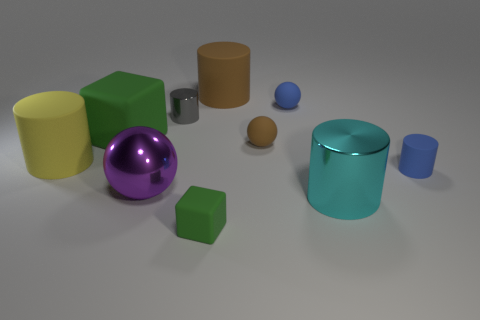There is a rubber thing that is behind the gray cylinder and left of the brown ball; how big is it?
Your response must be concise. Large. There is a green thing that is to the left of the large purple metal object; is its shape the same as the green thing that is in front of the large purple metallic object?
Keep it short and to the point. Yes. There is a object that is the same color as the large cube; what is its shape?
Your answer should be very brief. Cube. How many large yellow blocks are the same material as the small green object?
Make the answer very short. 0. What is the shape of the small object that is to the left of the brown rubber cylinder and behind the small blue rubber cylinder?
Your answer should be compact. Cylinder. Does the blue object that is in front of the blue sphere have the same material as the purple ball?
Provide a succinct answer. No. The block that is the same size as the blue ball is what color?
Make the answer very short. Green. Are there any rubber balls of the same color as the small matte cylinder?
Your response must be concise. Yes. What size is the other cylinder that is made of the same material as the large cyan cylinder?
Offer a very short reply. Small. There is another cube that is the same color as the big rubber block; what size is it?
Offer a terse response. Small. 